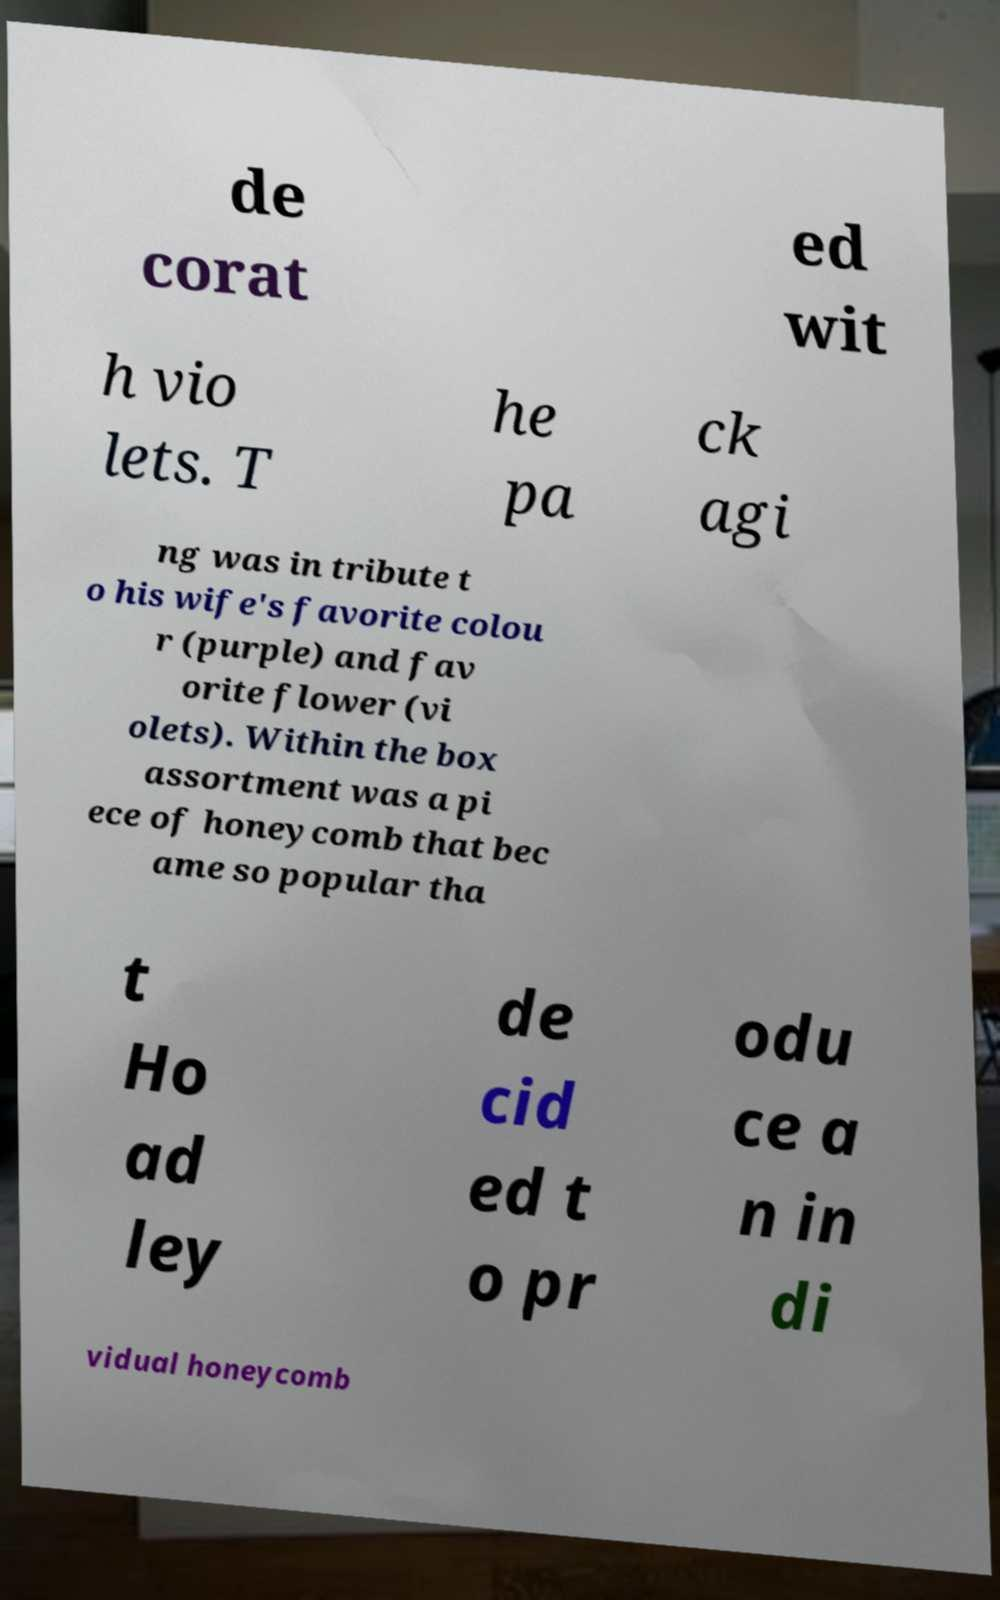For documentation purposes, I need the text within this image transcribed. Could you provide that? de corat ed wit h vio lets. T he pa ck agi ng was in tribute t o his wife's favorite colou r (purple) and fav orite flower (vi olets). Within the box assortment was a pi ece of honeycomb that bec ame so popular tha t Ho ad ley de cid ed t o pr odu ce a n in di vidual honeycomb 